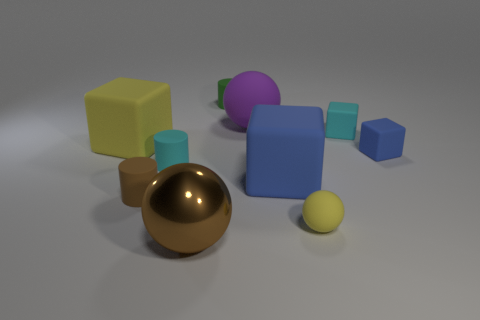Subtract all cylinders. How many objects are left? 7 Add 6 cylinders. How many cylinders are left? 9 Add 1 big matte objects. How many big matte objects exist? 4 Subtract 1 brown cylinders. How many objects are left? 9 Subtract all tiny blue rubber cubes. Subtract all blue objects. How many objects are left? 7 